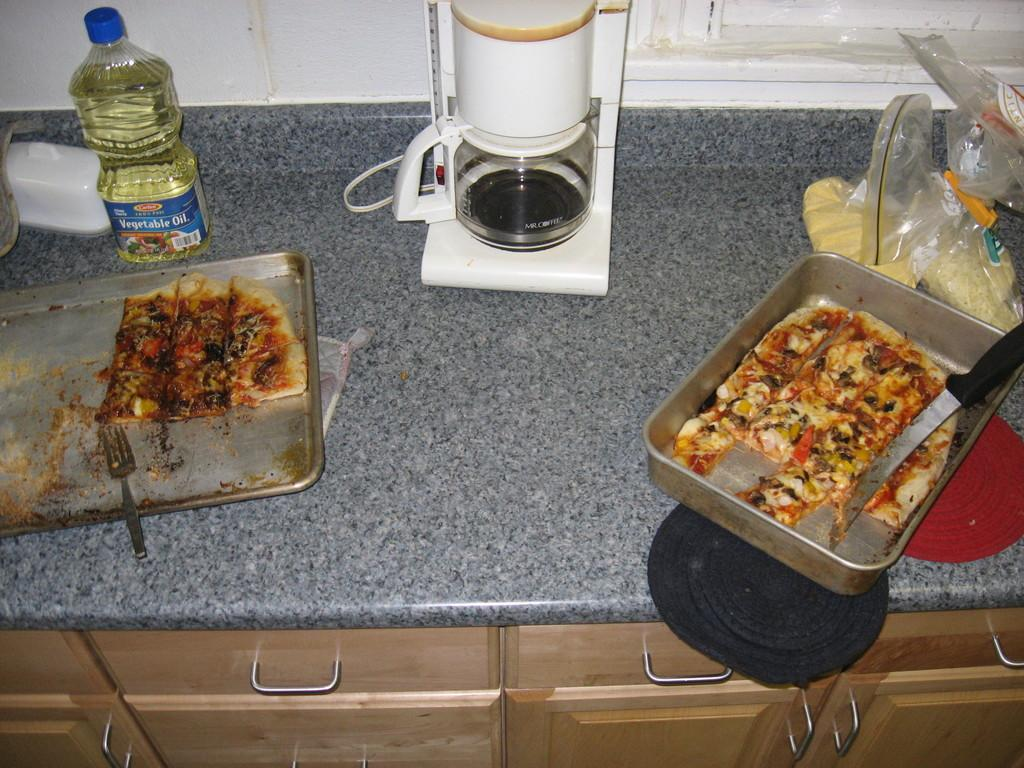<image>
Present a compact description of the photo's key features. A bottle of vegetable oil sits near a coffee maker on a kitchen counter. 